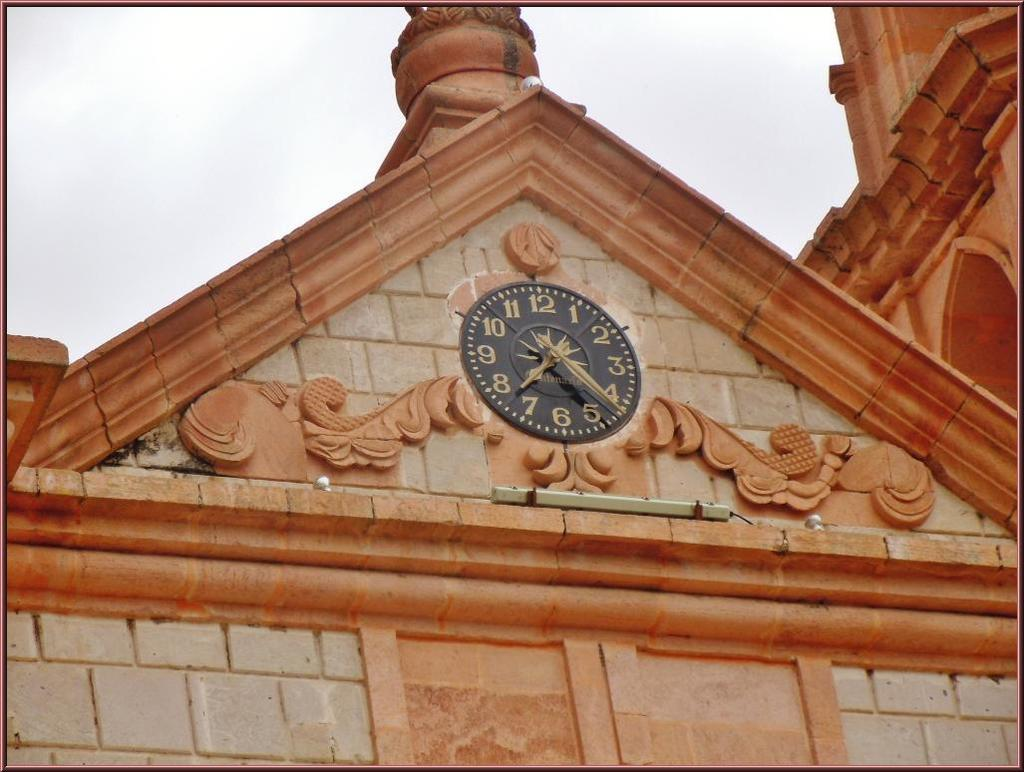<image>
Present a compact description of the photo's key features. A black clock shows the time at "7:22." 